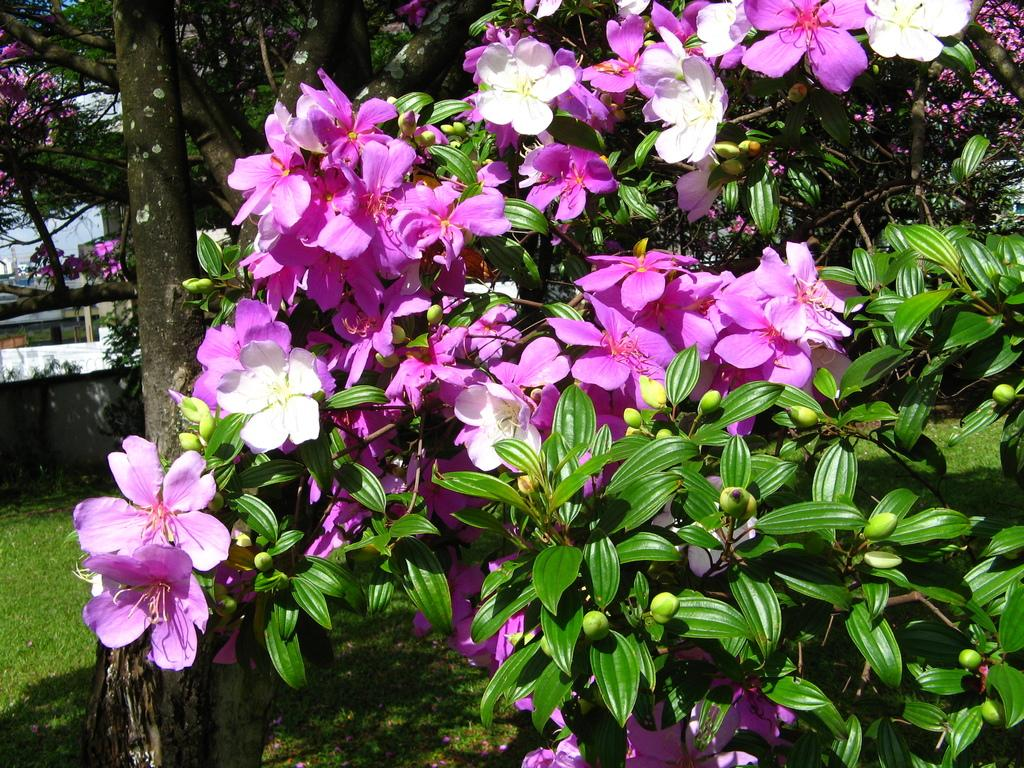What type of vegetation can be seen in the image? There are plants, flowers, and trees in the image. What is the ground like in the image? The ground is visible in the image and has grass. What part of the natural environment is visible in the image? The sky is visible in the image. What is located on the left side of the image? There are objects on the left side of the image. What type of pollution can be seen in the image? There is no pollution visible in the image; it features plants, flowers, trees, grass, and the sky. What is the source of fear in the image? There is no fear or any indication of fear in the image; it is a peaceful scene with vegetation and the sky. 